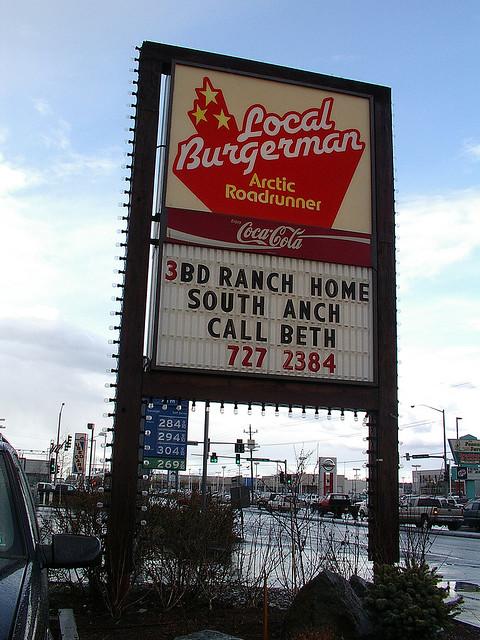Why would an out of towner find it difficult to contact Beth?
Concise answer only. No area code. What numbers are there?
Concise answer only. 37272384. What does the sign  read?
Keep it brief. Local burgerman. Do burgers contain red meat?
Quick response, please. Yes. 